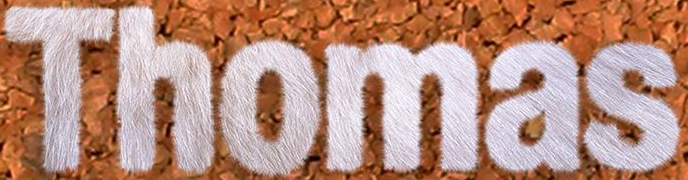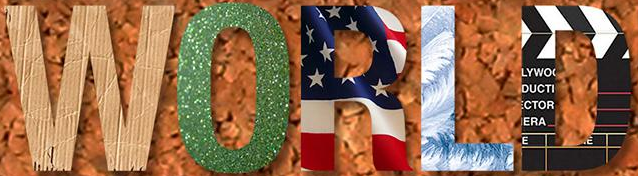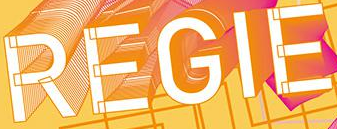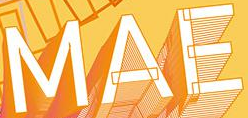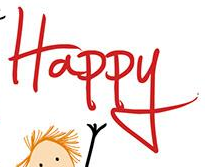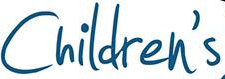Transcribe the words shown in these images in order, separated by a semicolon. Thomas; WORLD; REGIE; MAE; Happy; Children's 